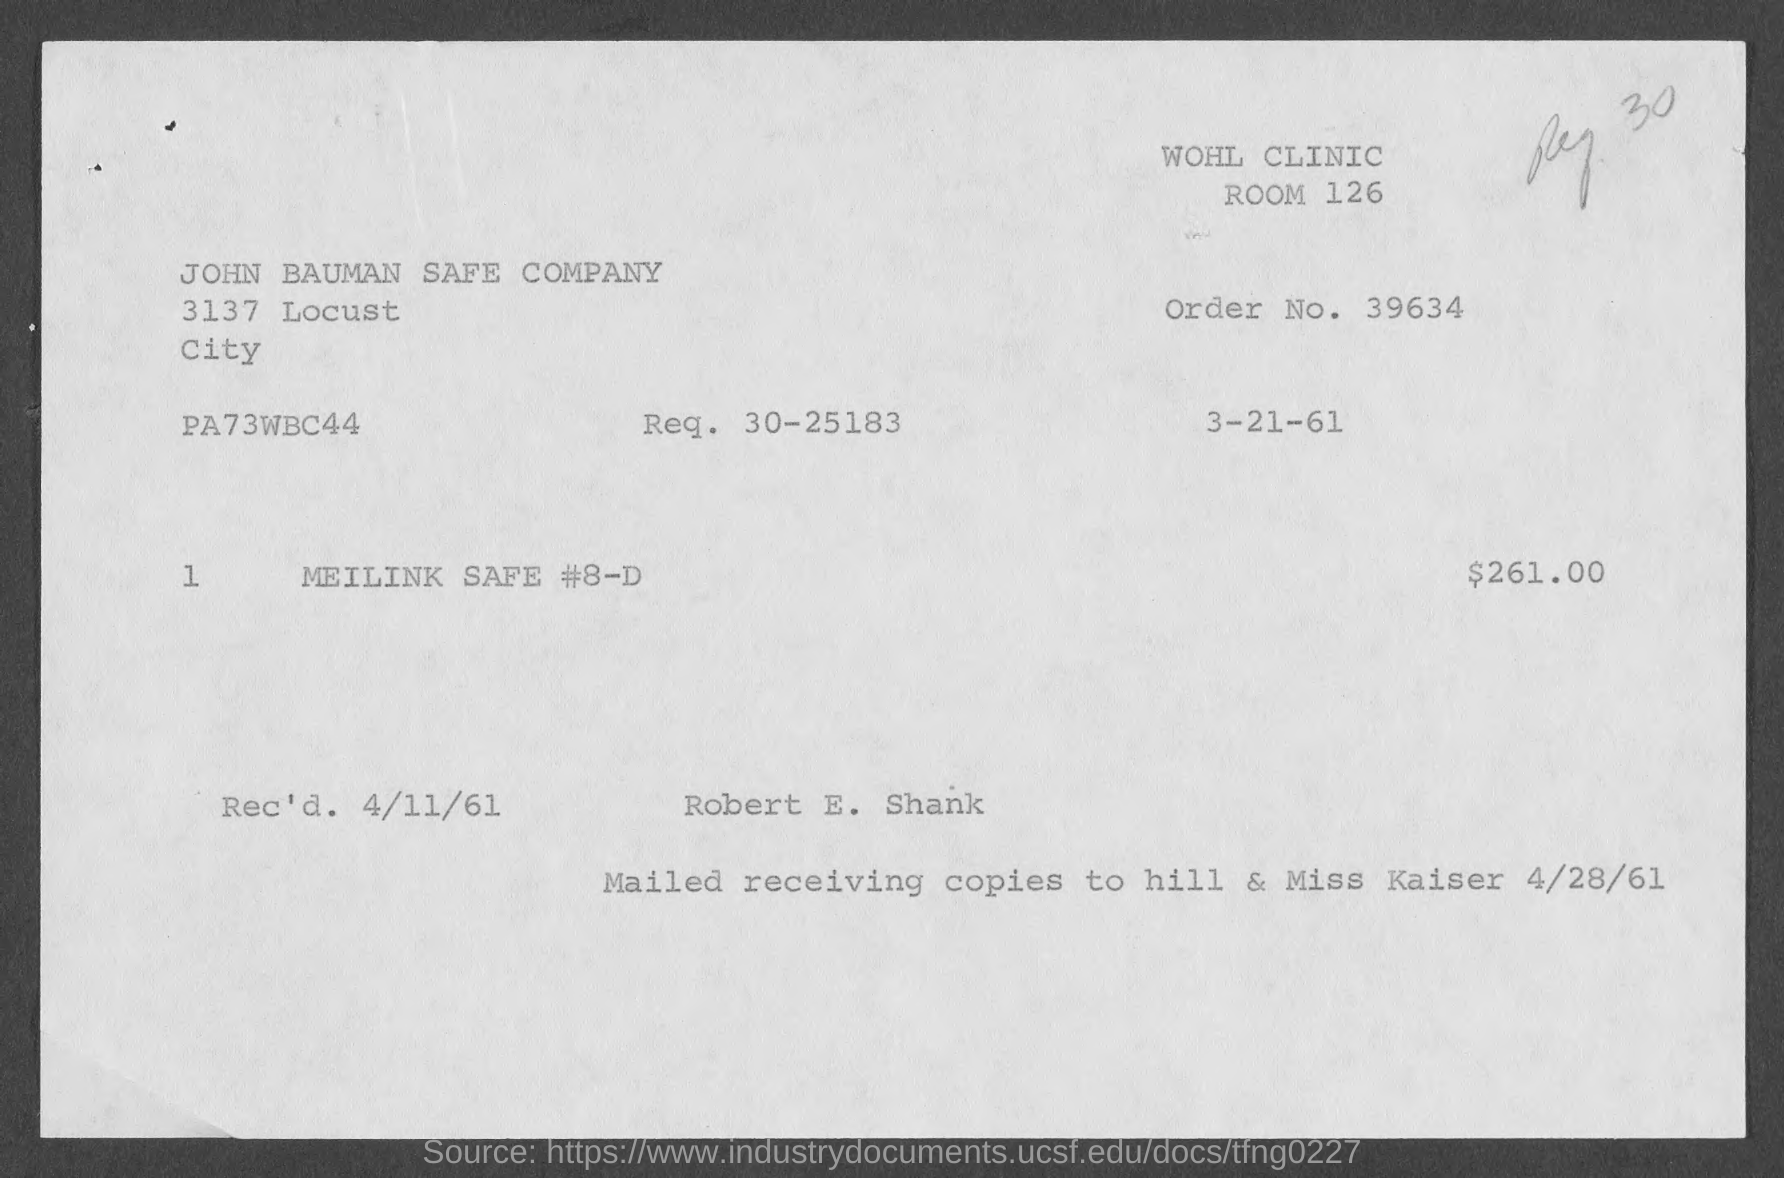Draw attention to some important aspects in this diagram. The room number is 126. The name of the company is John Bauman Safe Company. The order number is 39634... The price is 261.00. 